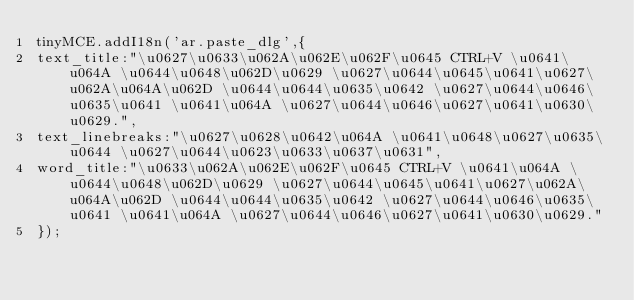Convert code to text. <code><loc_0><loc_0><loc_500><loc_500><_JavaScript_>tinyMCE.addI18n('ar.paste_dlg',{
text_title:"\u0627\u0633\u062A\u062E\u062F\u0645 CTRL+V \u0641\u064A \u0644\u0648\u062D\u0629 \u0627\u0644\u0645\u0641\u0627\u062A\u064A\u062D \u0644\u0644\u0635\u0642 \u0627\u0644\u0646\u0635\u0641 \u0641\u064A \u0627\u0644\u0646\u0627\u0641\u0630\u0629.",
text_linebreaks:"\u0627\u0628\u0642\u064A \u0641\u0648\u0627\u0635\u0644 \u0627\u0644\u0623\u0633\u0637\u0631",
word_title:"\u0633\u062A\u062E\u062F\u0645 CTRL+V \u0641\u064A \u0644\u0648\u062D\u0629 \u0627\u0644\u0645\u0641\u0627\u062A\u064A\u062D \u0644\u0644\u0635\u0642 \u0627\u0644\u0646\u0635\u0641 \u0641\u064A \u0627\u0644\u0646\u0627\u0641\u0630\u0629."
});</code> 